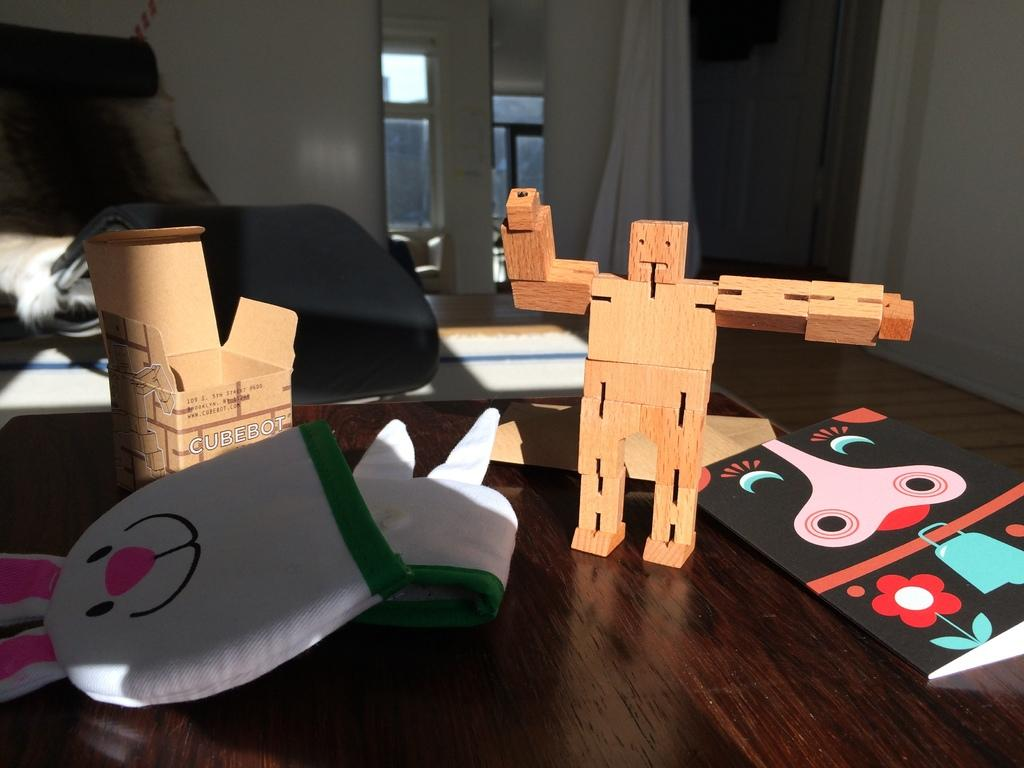<image>
Give a short and clear explanation of the subsequent image. the word cubebot that is on an item 